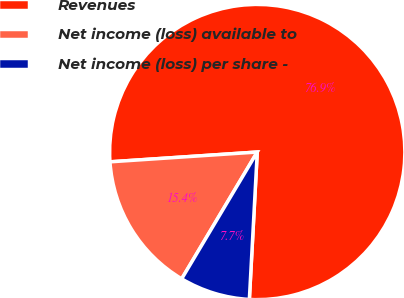<chart> <loc_0><loc_0><loc_500><loc_500><pie_chart><fcel>Revenues<fcel>Net income (loss) available to<fcel>Net income (loss) per share -<nl><fcel>76.91%<fcel>15.39%<fcel>7.7%<nl></chart> 